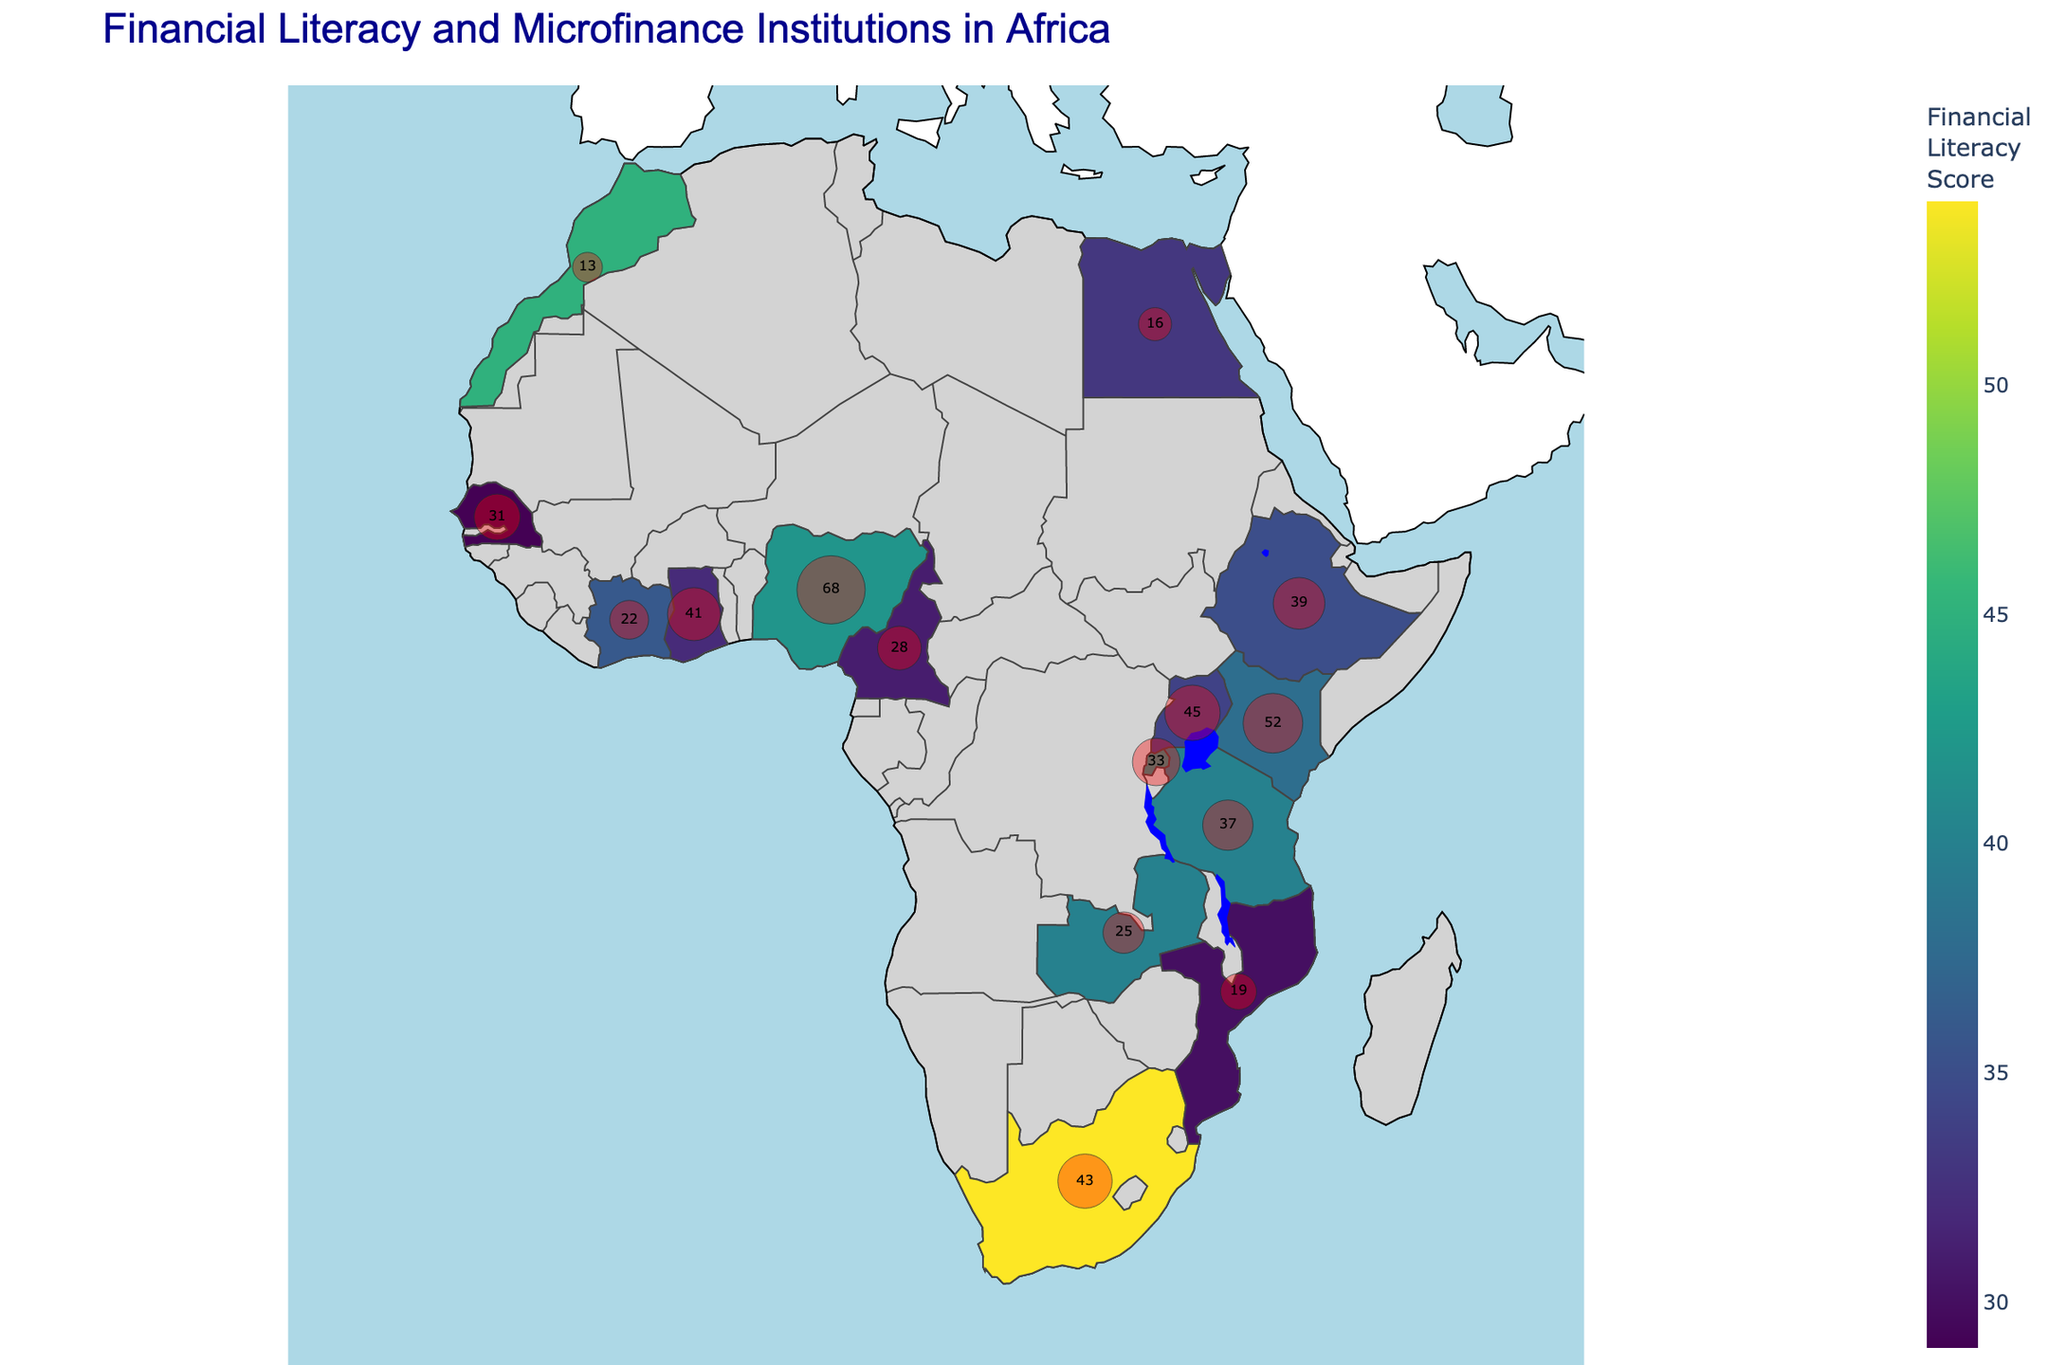What country has the highest financial literacy score? By looking at the data on the plot, the country with the highest shaded color indicates the highest financial literacy score.
Answer: South Africa Which country has the most microfinance institutions? The plot also includes markers representing the number of microfinance institutions. The country with the largest marker is the one with the most microfinance institutions.
Answer: Nigeria How does the number of microfinance institutions in Kenya compare to that in Zambia? By looking at the markers on the map, Kenya has larger markers than Zambia, indicating that Kenya has more microfinance institutions.
Answer: Kenya has more What's the average financial literacy score of the countries shown in the map? To find the average, add up all the financial literacy scores and divide by the number of countries. (42+38+54+32+40+34+33+45+29+35+31+40+42+36+30)/15
Answer: 37.67 How does the financial literacy score of Morocco compare to Egypt? The map shows the financial literacy scores with different shades. By comparing the respective shades of Morocco and Egypt, we can see that Morocco's score is higher.
Answer: Morocco's score is higher Which country has the lowest number of microfinance institutions? The smallest marker on the plot indicates the country with the lowest number of microfinance institutions.
Answer: Morocco What is the combined total number of microfinance institutions in Tanzania and Uganda? Sum the number of microfinance institutions in Tanzania and Uganda from the data provided. 37 (Tanzania) + 45 (Uganda) = 82
Answer: 82 Is there a visible correlation between financial literacy scores and the presence of microfinance institutions? By observing the pattern on the map, countries with high financial literacy scores do not necessarily have the most microfinance institutions and vice versa. This scatter distribution suggests no direct correlation.
Answer: No direct correlation What is the median financial literacy score of the countries listed? Arrange the financial literacy scores in ascending order and find the middle value. (29, 30, 31, 32, 33, 34, 35, 36, 38, 40, 40, 42, 42, 45, 54). As there are 15 countries, the median is the 8th value, which is 36.
Answer: 36 